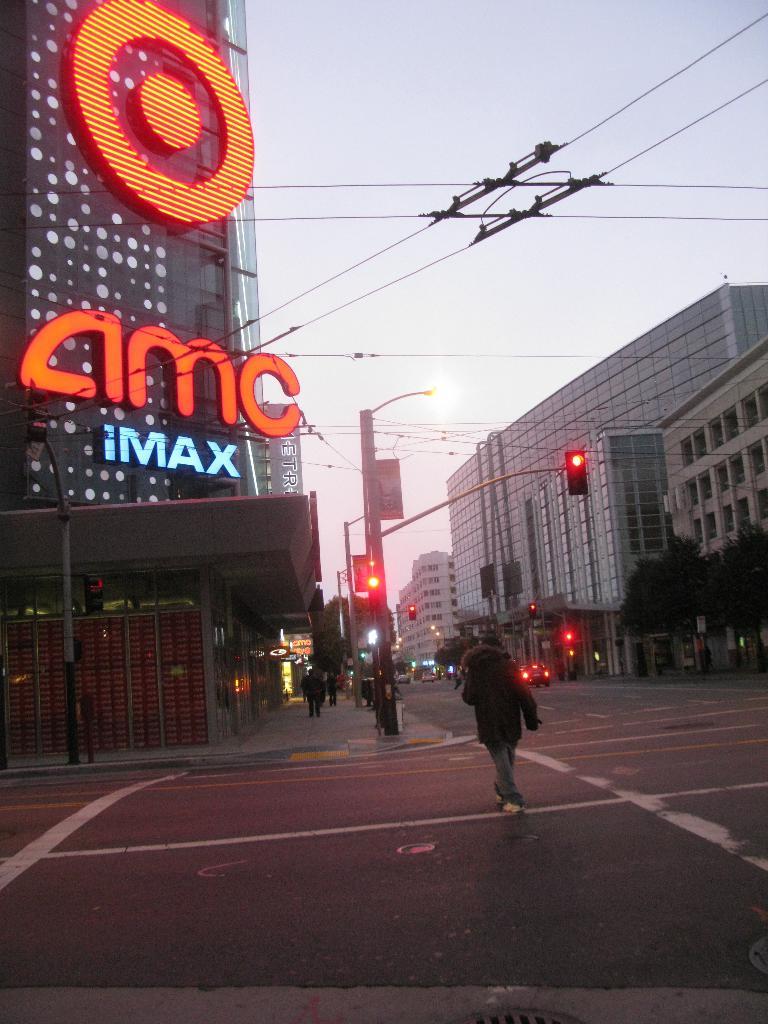Is she a traffic cop in times square?
Offer a terse response. No. 